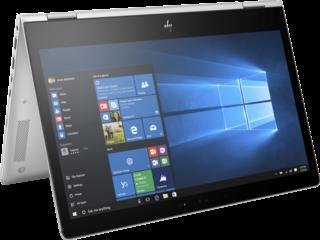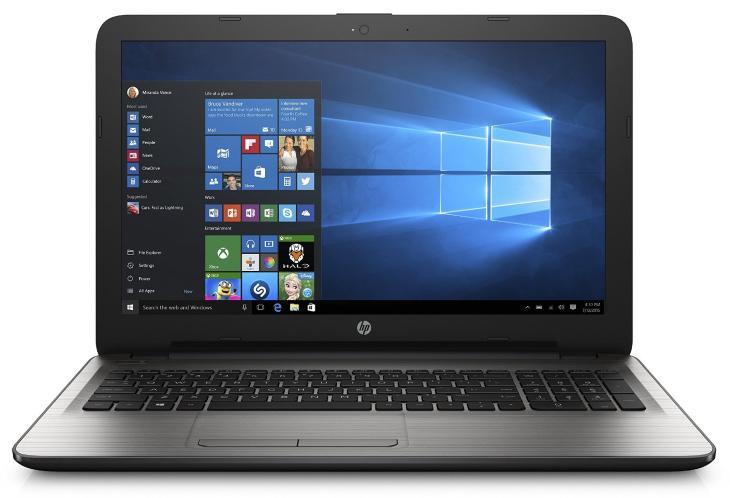The first image is the image on the left, the second image is the image on the right. For the images displayed, is the sentence "The image on the left shows a laptop with the keyboard not visible so it can be used as a tablet." factually correct? Answer yes or no. Yes. The first image is the image on the left, the second image is the image on the right. For the images shown, is this caption "One of the laptops is standing tent-like, with an image displaying outward on the inverted screen." true? Answer yes or no. Yes. 